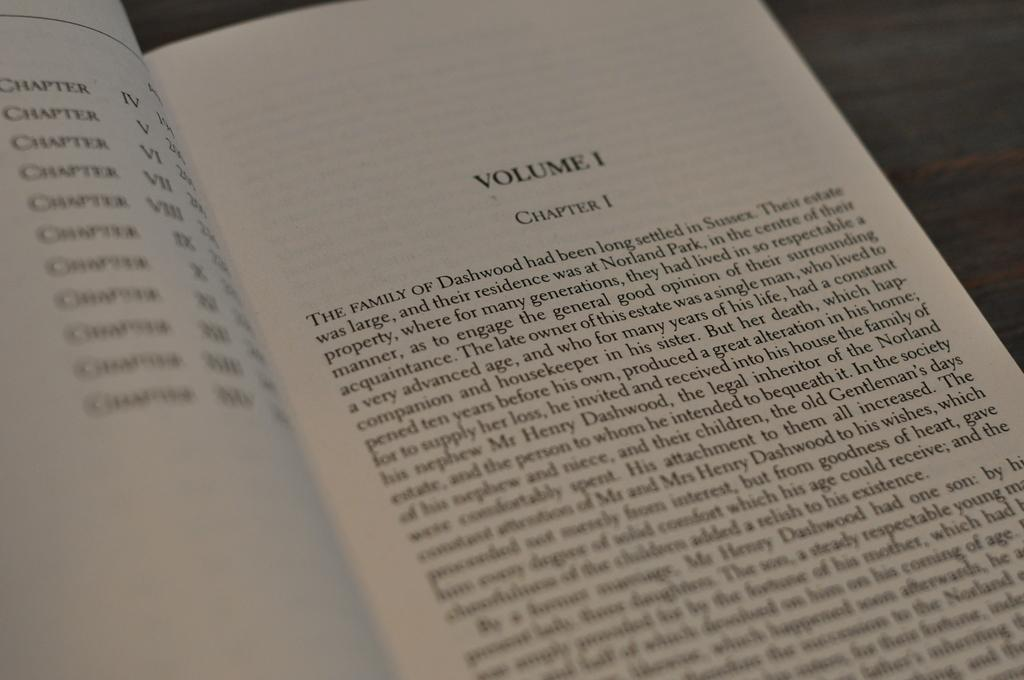<image>
Present a compact description of the photo's key features. A book opened up to Volume one chapter one. 